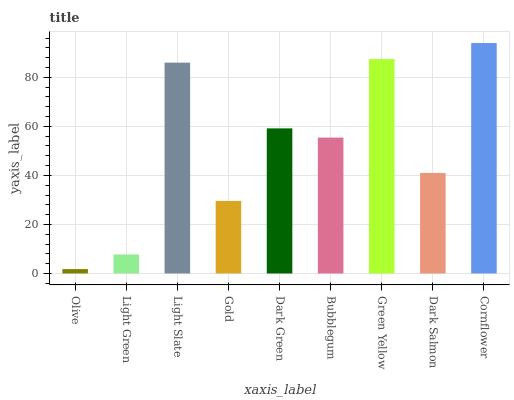Is Olive the minimum?
Answer yes or no. Yes. Is Cornflower the maximum?
Answer yes or no. Yes. Is Light Green the minimum?
Answer yes or no. No. Is Light Green the maximum?
Answer yes or no. No. Is Light Green greater than Olive?
Answer yes or no. Yes. Is Olive less than Light Green?
Answer yes or no. Yes. Is Olive greater than Light Green?
Answer yes or no. No. Is Light Green less than Olive?
Answer yes or no. No. Is Bubblegum the high median?
Answer yes or no. Yes. Is Bubblegum the low median?
Answer yes or no. Yes. Is Gold the high median?
Answer yes or no. No. Is Green Yellow the low median?
Answer yes or no. No. 